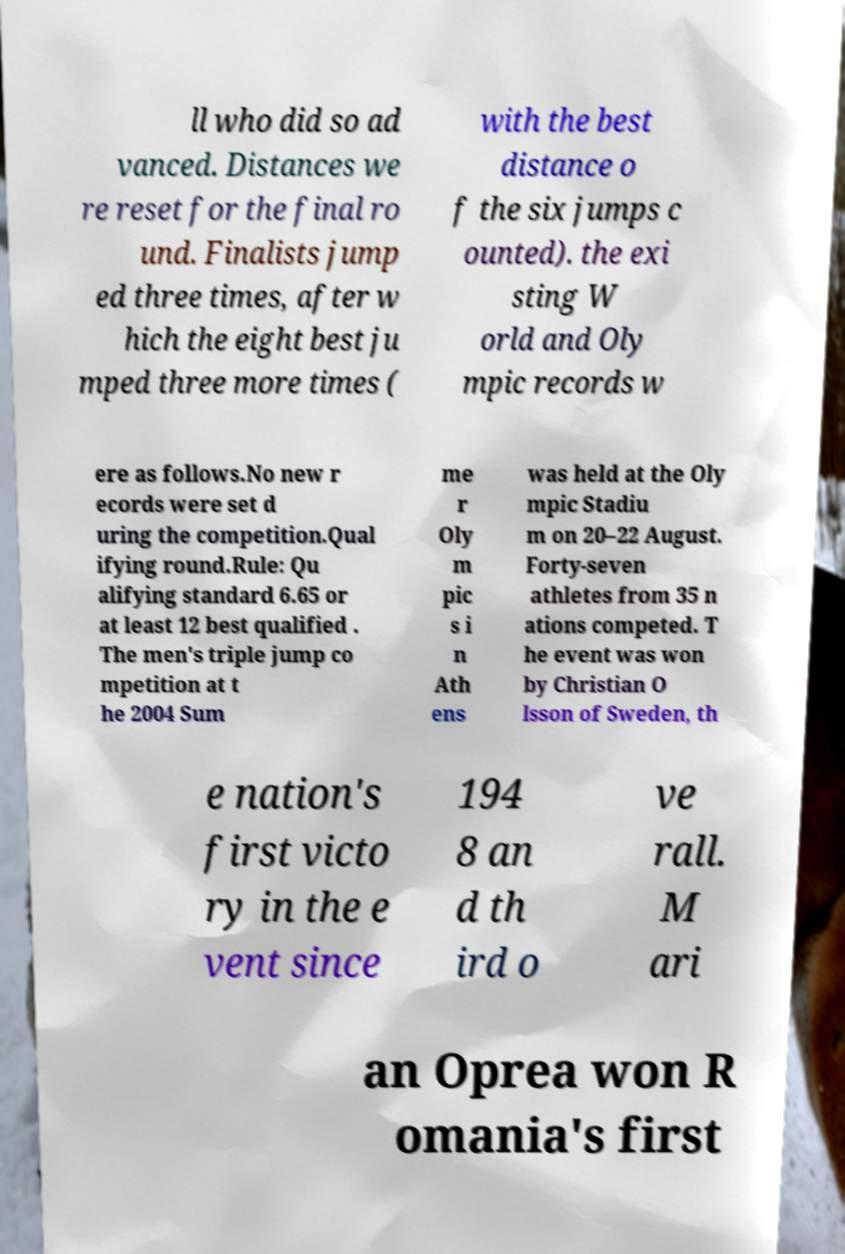Please read and relay the text visible in this image. What does it say? ll who did so ad vanced. Distances we re reset for the final ro und. Finalists jump ed three times, after w hich the eight best ju mped three more times ( with the best distance o f the six jumps c ounted). the exi sting W orld and Oly mpic records w ere as follows.No new r ecords were set d uring the competition.Qual ifying round.Rule: Qu alifying standard 6.65 or at least 12 best qualified . The men's triple jump co mpetition at t he 2004 Sum me r Oly m pic s i n Ath ens was held at the Oly mpic Stadiu m on 20–22 August. Forty-seven athletes from 35 n ations competed. T he event was won by Christian O lsson of Sweden, th e nation's first victo ry in the e vent since 194 8 an d th ird o ve rall. M ari an Oprea won R omania's first 